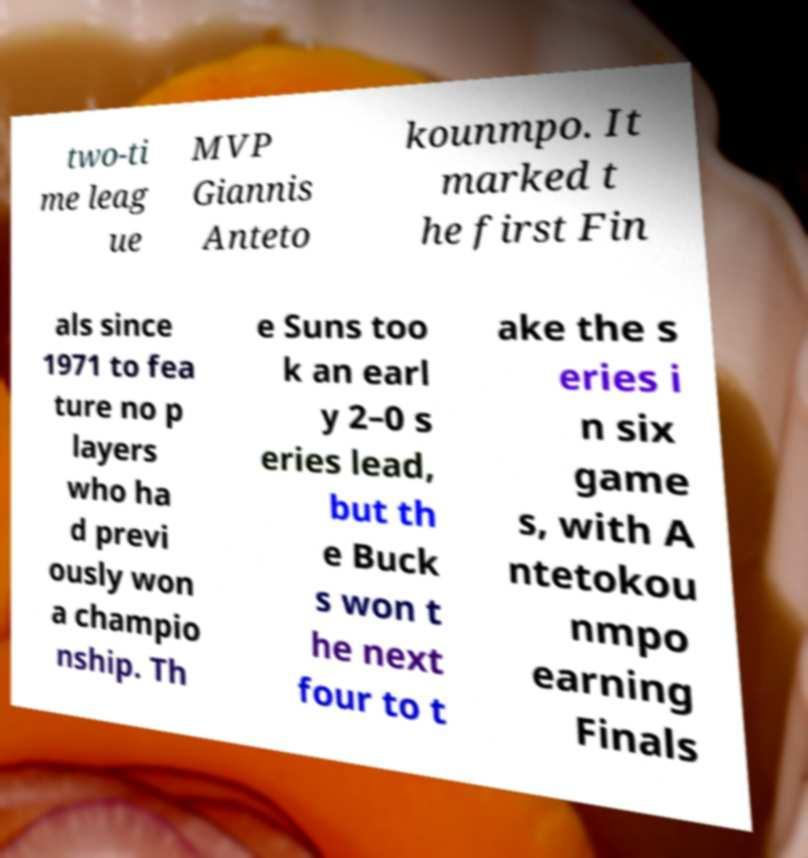What messages or text are displayed in this image? I need them in a readable, typed format. two-ti me leag ue MVP Giannis Anteto kounmpo. It marked t he first Fin als since 1971 to fea ture no p layers who ha d previ ously won a champio nship. Th e Suns too k an earl y 2–0 s eries lead, but th e Buck s won t he next four to t ake the s eries i n six game s, with A ntetokou nmpo earning Finals 